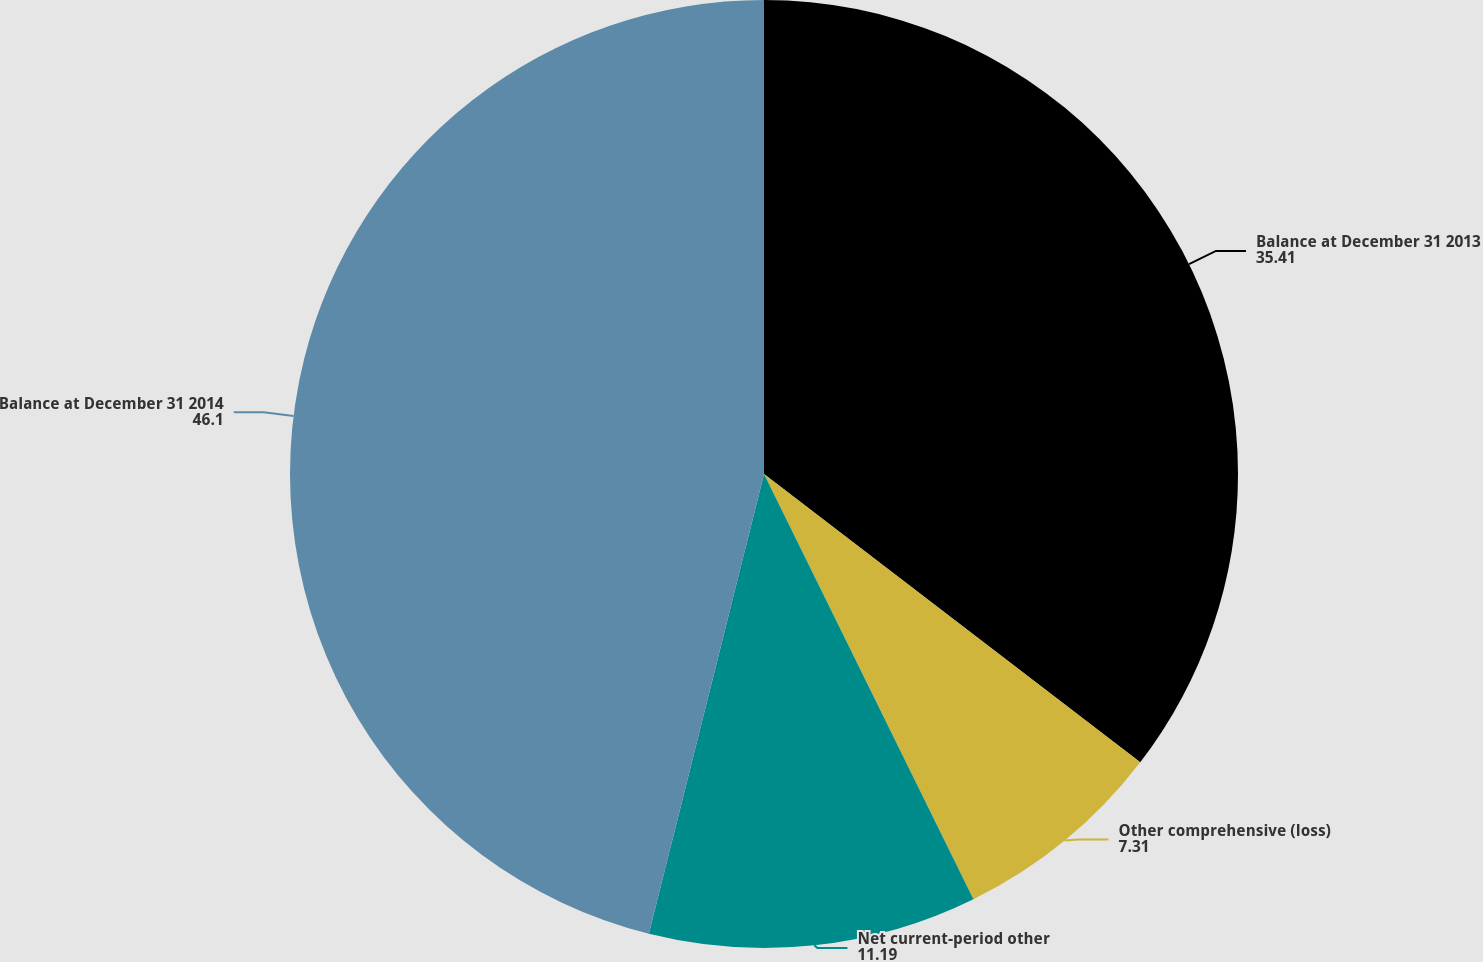<chart> <loc_0><loc_0><loc_500><loc_500><pie_chart><fcel>Balance at December 31 2013<fcel>Other comprehensive (loss)<fcel>Net current-period other<fcel>Balance at December 31 2014<nl><fcel>35.41%<fcel>7.31%<fcel>11.19%<fcel>46.1%<nl></chart> 